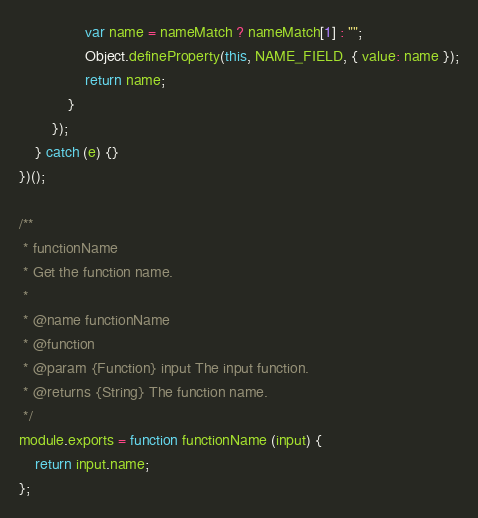Convert code to text. <code><loc_0><loc_0><loc_500><loc_500><_JavaScript_>                var name = nameMatch ? nameMatch[1] : "";
                Object.defineProperty(this, NAME_FIELD, { value: name });
                return name;
            }
        });
    } catch (e) {}
})();

/**
 * functionName
 * Get the function name.
 *
 * @name functionName
 * @function
 * @param {Function} input The input function.
 * @returns {String} The function name.
 */
module.exports = function functionName (input) {
    return input.name;
};
</code> 